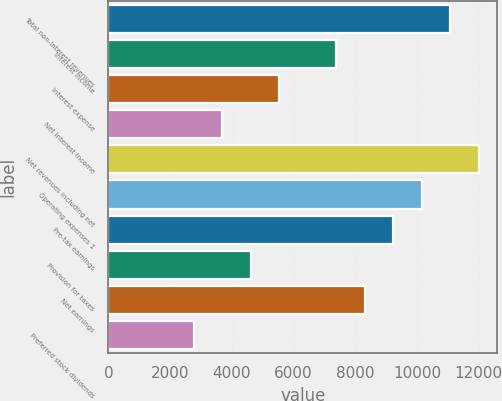Convert chart to OTSL. <chart><loc_0><loc_0><loc_500><loc_500><bar_chart><fcel>Total non-interest revenues<fcel>Interest income<fcel>Interest expense<fcel>Net interest income<fcel>Net revenues including net<fcel>Operating expenses 1<fcel>Pre-tax earnings<fcel>Provision for taxes<fcel>Net earnings<fcel>Preferred stock dividends<nl><fcel>11083.1<fcel>7388.9<fcel>5541.8<fcel>3694.7<fcel>12006.6<fcel>10159.5<fcel>9236<fcel>4618.25<fcel>8312.45<fcel>2771.15<nl></chart> 